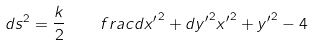Convert formula to latex. <formula><loc_0><loc_0><loc_500><loc_500>d s ^ { 2 } = \frac { k } { 2 } \quad f r a c { { d x ^ { \prime } } ^ { 2 } + { d y ^ { \prime } } ^ { 2 } } { { x ^ { \prime } } ^ { 2 } + { y ^ { \prime } } ^ { 2 } - 4 }</formula> 